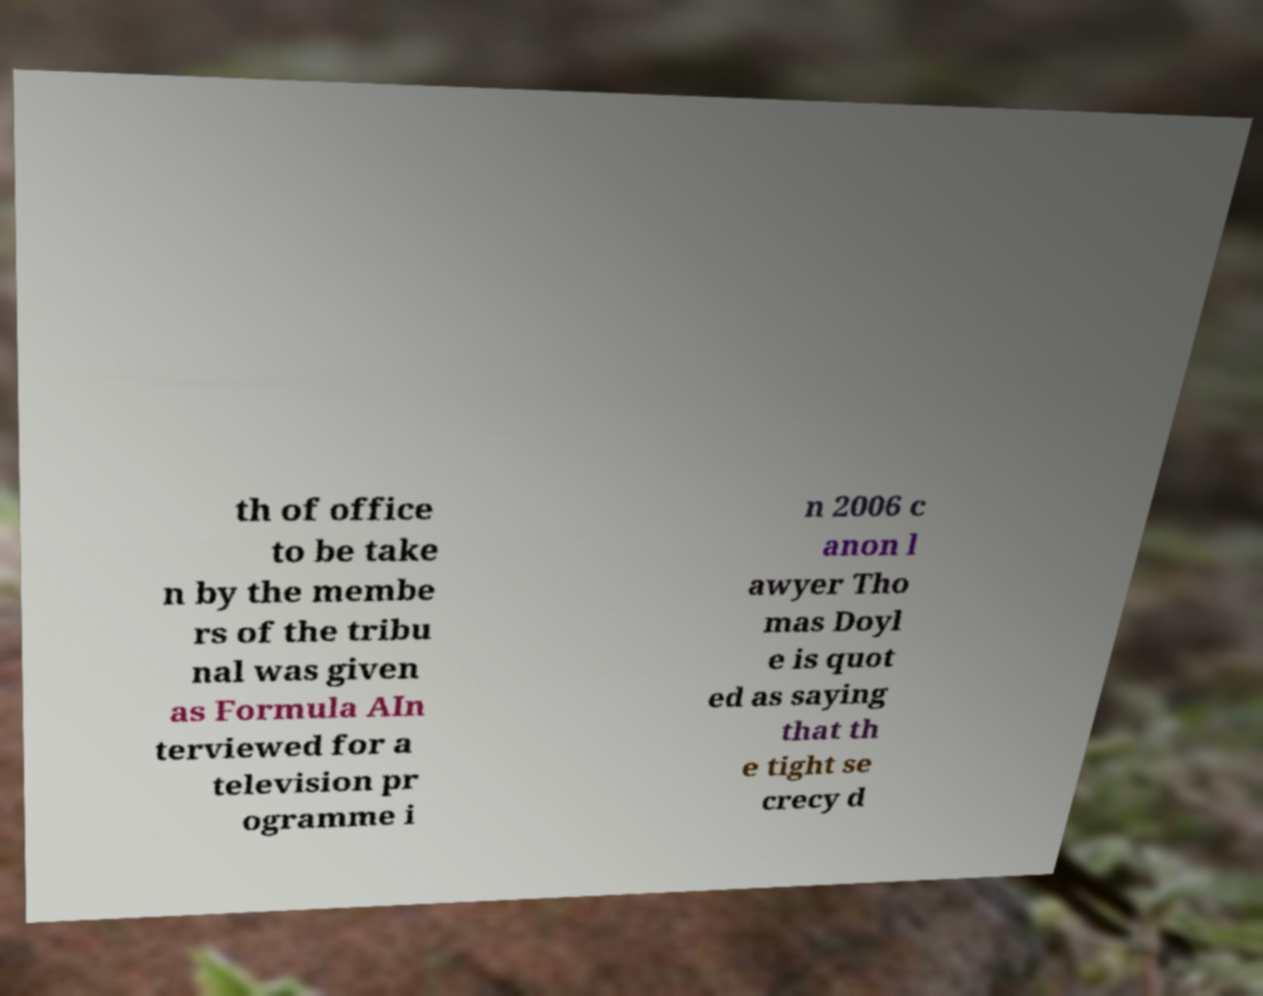I need the written content from this picture converted into text. Can you do that? th of office to be take n by the membe rs of the tribu nal was given as Formula AIn terviewed for a television pr ogramme i n 2006 c anon l awyer Tho mas Doyl e is quot ed as saying that th e tight se crecy d 